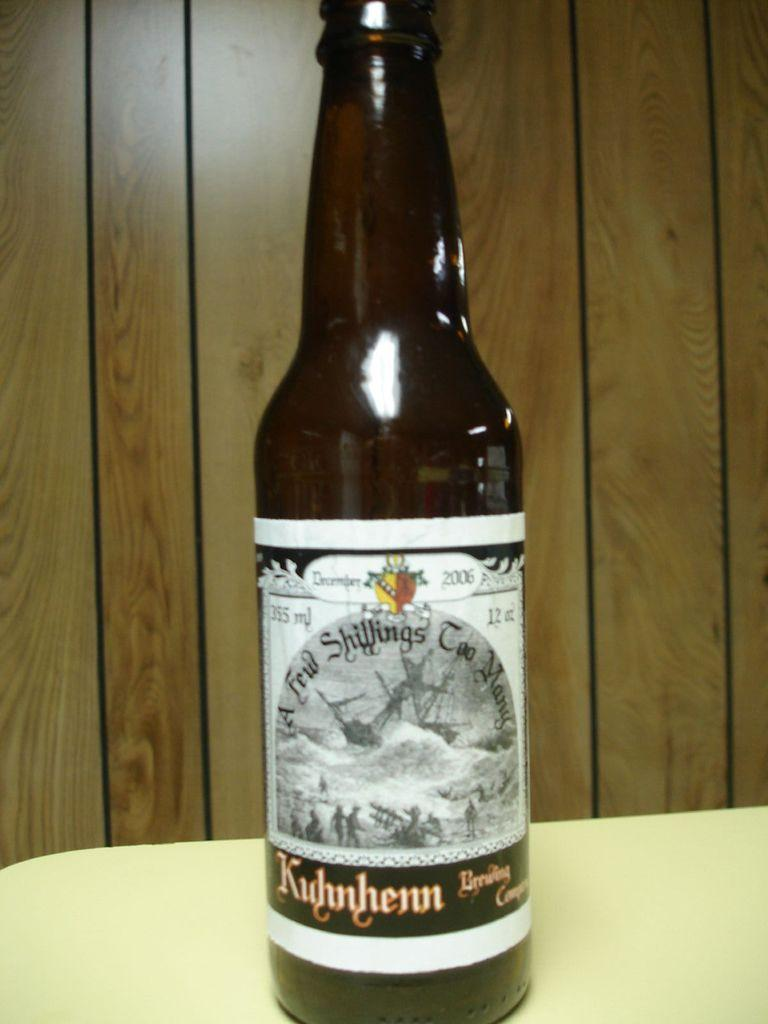<image>
Offer a succinct explanation of the picture presented. A bottle of beer from A Few Shillings Too Many. 